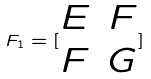<formula> <loc_0><loc_0><loc_500><loc_500>F _ { 1 } = [ \begin{matrix} E & F \\ F & G \end{matrix} ]</formula> 